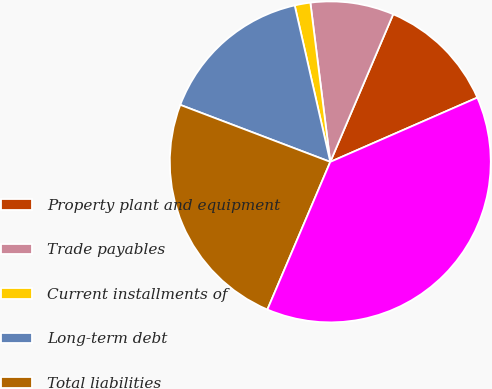Convert chart to OTSL. <chart><loc_0><loc_0><loc_500><loc_500><pie_chart><fcel>Property plant and equipment<fcel>Trade payables<fcel>Current installments of<fcel>Long-term debt<fcel>Total liabilities<fcel>Maximum exposure to loss<nl><fcel>12.03%<fcel>8.39%<fcel>1.58%<fcel>15.66%<fcel>24.37%<fcel>37.97%<nl></chart> 